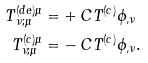<formula> <loc_0><loc_0><loc_500><loc_500>T ^ { ( d e ) \mu } _ { \, \nu ; \mu } = & + C T ^ { ( c ) } \phi _ { , \nu } \\ T ^ { ( c ) \mu } _ { \nu ; \mu } = & - C T ^ { ( c ) } \phi _ { , \nu } .</formula> 